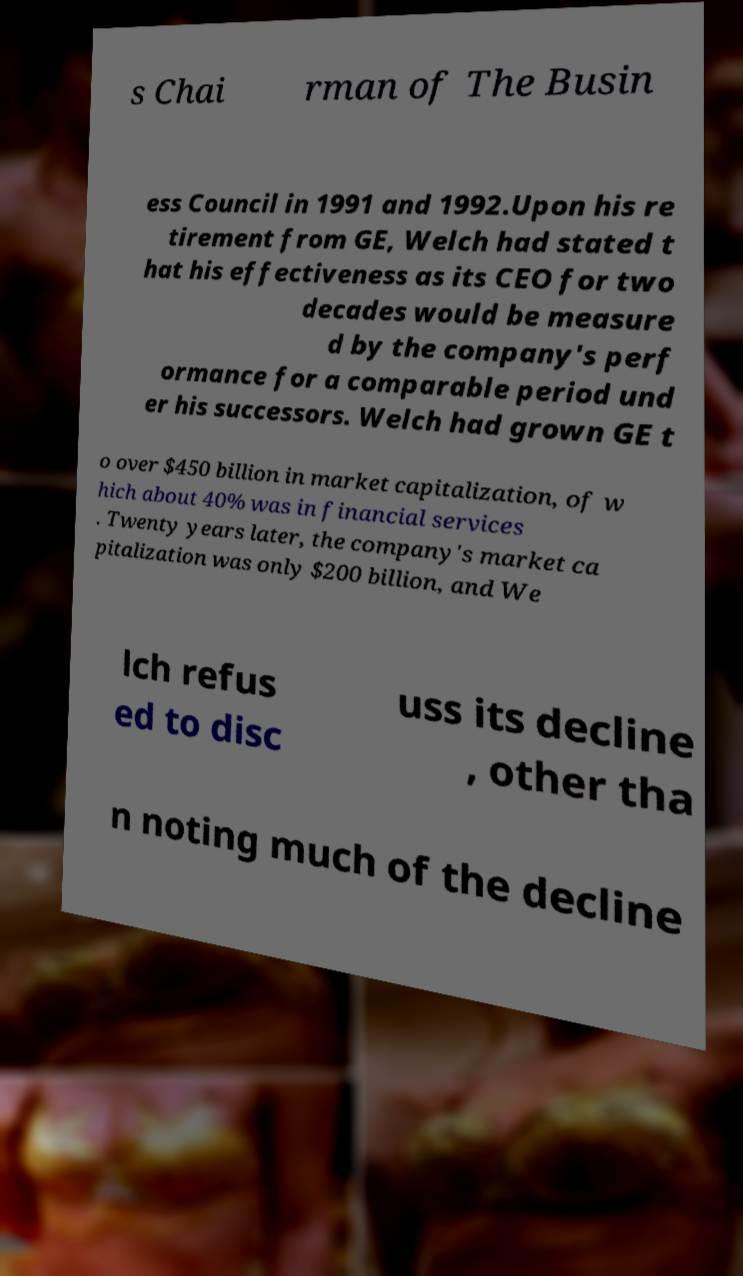Please identify and transcribe the text found in this image. s Chai rman of The Busin ess Council in 1991 and 1992.Upon his re tirement from GE, Welch had stated t hat his effectiveness as its CEO for two decades would be measure d by the company's perf ormance for a comparable period und er his successors. Welch had grown GE t o over $450 billion in market capitalization, of w hich about 40% was in financial services . Twenty years later, the company's market ca pitalization was only $200 billion, and We lch refus ed to disc uss its decline , other tha n noting much of the decline 